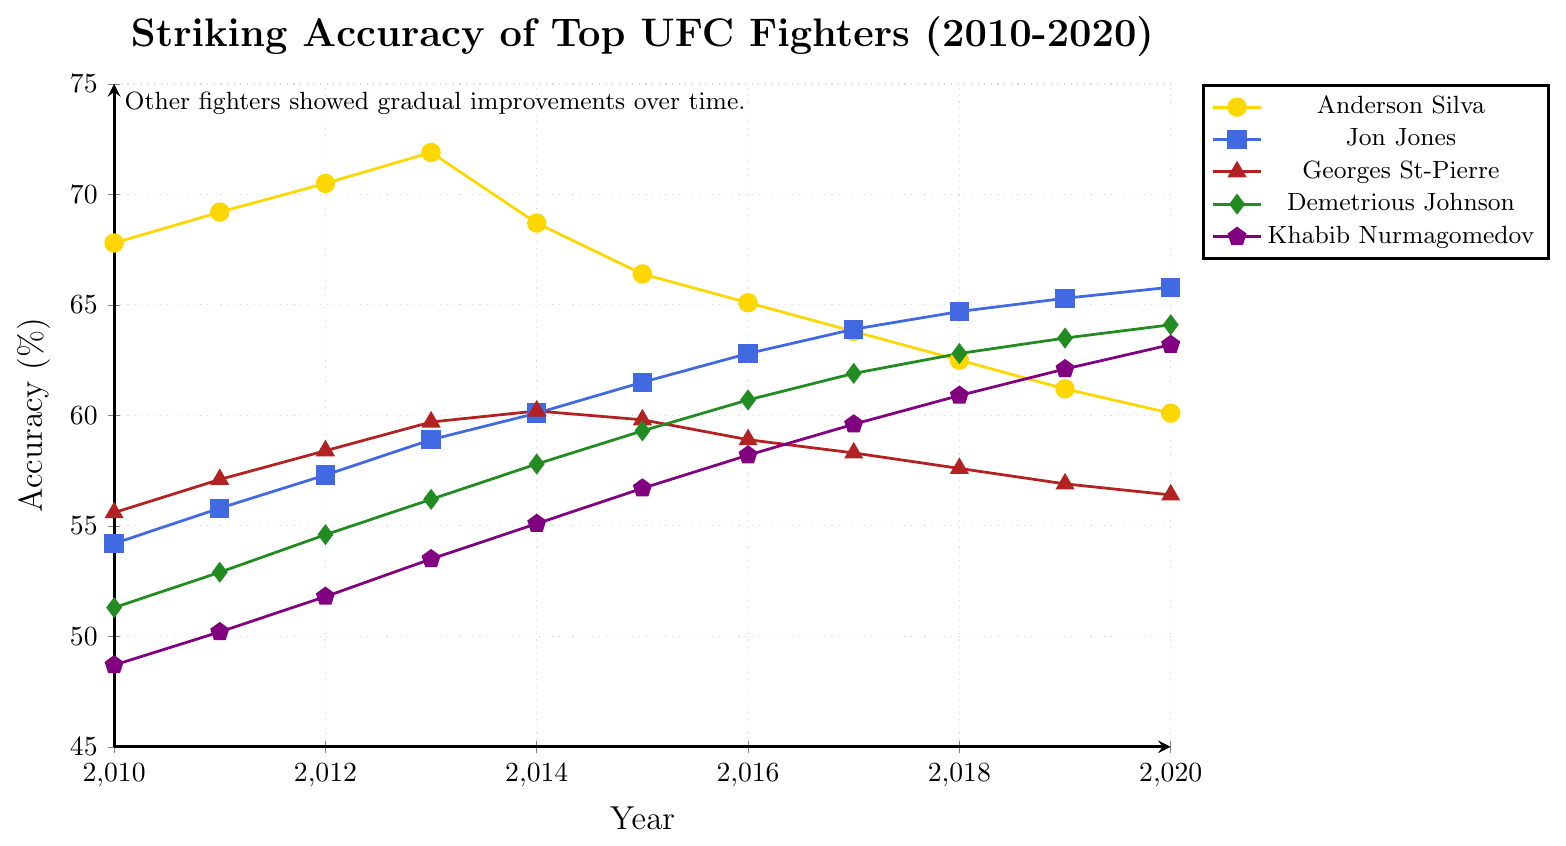Which fighter had the highest striking accuracy in 2013? Look at the data points for each fighter in 2013, identify the highest value, which is for Anderson Silva at 71.9%.
Answer: Anderson Silva Which fighter showed the most consistent improvement in striking accuracy from 2010 to 2020? Determine whose line primarily trends upwards without significant drops. This applies to Jon Jones, with consistent improvements each year.
Answer: Jon Jones What is the difference in striking accuracy between Anderson Silva and Khabib Nurmagomedov in 2020? Subtract Khabib Nurmagomedov's accuracy in 2020 (63.2%) from Anderson Silva's in the same year (60.1%).
Answer: 3.1% Compare the striking accuracy of Georges St-Pierre in 2014 and 2020. How does it change? Look at Georges St-Pierre's accuracy value in 2014 (60.2%) and in 2020 (56.4%). Subtract the latter from the former to find the decline.
Answer: Decrease of 3.8% Whose striking accuracy exceeded 70% in any given year? Check which fighter's accuracy values exceed 70% in the timeframe. Anderson Silva's accuracy exceeds 70% in 2012 and 2013.
Answer: Anderson Silva Between 2015 and 2020, who had the highest overall increase in striking accuracy? Calculate the difference between 2015 and 2020 for each fighter and determine the highest increase. Demetrious Johnson's accuracy increased from 59.3% to 64.1%, the largest rise of 4.8%.
Answer: Demetrious Johnson By how much did Jon Jones improve from 2010 to 2014? Subtract Jon Jones' accuracy in 2010 (54.2%) from his accuracy in 2014 (60.1%).
Answer: 5.9% Which fighter had the lowest striking accuracy in 2016? Identify the lowest value among the fighters' accuracy in 2016, which is Anderson Silva at 65.1%.
Answer: Anderson Silva What is the average striking accuracy of Khabib Nurmagomedov from 2010 to 2015? Sum the annual accuracies of Khabib Nurmagomedov from 2010 to 2015 and divide by the number of years. (48.7 + 50.2 + 51.8 + 53.5 + 55.1 + 56.7) / 6 = 52.67%.
Answer: 52.67% Did Demetrious Johnson or Jon Jones have a higher striking accuracy in 2019? Compare their accuracies for 2019: Demetrious Johnson (63.5%) and Jon Jones (65.3%).
Answer: Jon Jones 